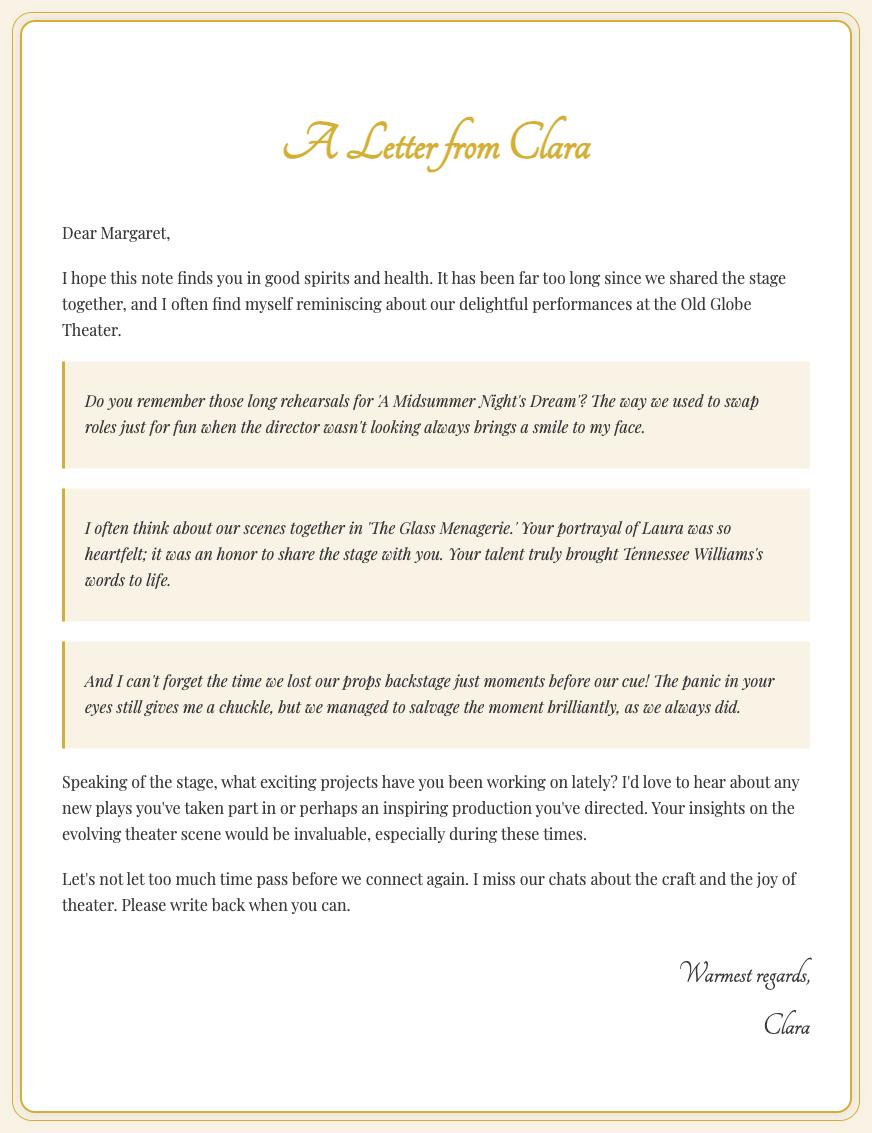What is the name of the sender? The sender of the letter is identified as Clara, mentioned at the end of the letter.
Answer: Clara What theater does Clara mention in the letter? Clara refers to the Old Globe Theater in her recollections.
Answer: Old Globe Theater Which play does Clara reminisce about with Margaret? Clara recalls their performances in 'A Midsummer Night's Dream' as a fond memory shared with Margaret.
Answer: 'A Midsummer Night's Dream' What role did Margaret play in 'The Glass Menagerie'? Clara notes that Margaret portrayed the character of Laura in 'The Glass Menagerie.'
Answer: Laura What is Clara's request to Margaret regarding her current projects? Clara inquires about any exciting projects or productions that Margaret has been involved with recently.
Answer: Exciting projects What specific emotion does Clara express when recalling their past performances? Clara expresses nostalgia and fondness for the delightful performances they shared together.
Answer: Nostalgia How does Clara sign off the letter? Clara concludes the letter with "Warmest regards," followed by her name.
Answer: Warmest regards What does Clara say about Margaret's portrayal of Laura? Clara describes Margaret's portrayal of Laura as heartfelt and an honor to witness.
Answer: Heartfelt What type of communication does Clara encourage between her and Margaret? Clara encourages Margaret to write back and reconnect, indicating a desire for ongoing communication.
Answer: Write back 